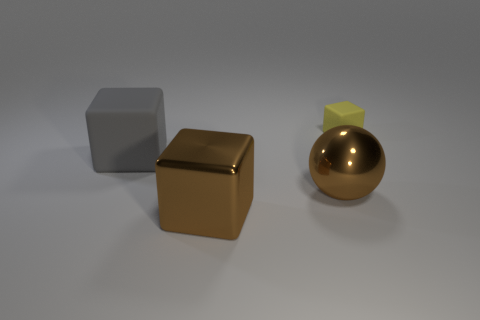Is the metallic block the same color as the ball?
Ensure brevity in your answer.  Yes. How many other things are there of the same color as the large metallic block?
Your answer should be compact. 1. There is a metallic sphere; does it have the same color as the metallic thing that is to the left of the brown metallic ball?
Your answer should be very brief. Yes. What material is the ball that is the same color as the big metal cube?
Your answer should be very brief. Metal. What is the size of the cube in front of the matte cube that is to the left of the rubber cube that is right of the big gray matte object?
Make the answer very short. Large. Does the gray block have the same size as the yellow thing?
Offer a terse response. No. Is the number of large matte cubes that are behind the big rubber thing less than the number of spheres that are behind the large brown block?
Ensure brevity in your answer.  Yes. Are there any other things that have the same size as the yellow rubber object?
Offer a terse response. No. How big is the yellow matte block?
Your answer should be compact. Small. What number of big things are metal objects or metallic spheres?
Make the answer very short. 2. 